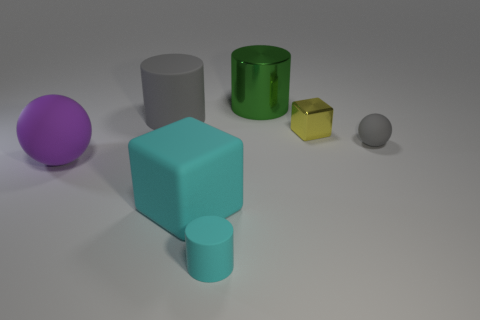Subtract all gray cubes. Subtract all green balls. How many cubes are left? 2 Add 3 large shiny balls. How many objects exist? 10 Subtract all spheres. How many objects are left? 5 Add 6 small gray cubes. How many small gray cubes exist? 6 Subtract 0 purple blocks. How many objects are left? 7 Subtract all rubber spheres. Subtract all large purple objects. How many objects are left? 4 Add 4 large rubber cubes. How many large rubber cubes are left? 5 